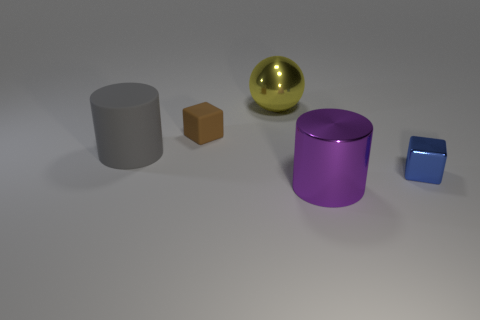What number of brown things are either tiny shiny things or tiny matte things?
Give a very brief answer. 1. How many big matte things have the same color as the tiny metallic block?
Ensure brevity in your answer.  0. Is there anything else that is the same shape as the big gray object?
Ensure brevity in your answer.  Yes. What number of spheres are either tiny shiny things or big rubber objects?
Make the answer very short. 0. What is the color of the big cylinder that is to the right of the yellow ball?
Keep it short and to the point. Purple. What is the shape of the rubber object that is the same size as the purple metallic cylinder?
Make the answer very short. Cylinder. There is a big matte object; what number of large purple objects are to the right of it?
Provide a succinct answer. 1. How many objects are big cylinders or yellow matte cylinders?
Your response must be concise. 2. The big object that is both right of the rubber cylinder and in front of the small matte cube has what shape?
Give a very brief answer. Cylinder. What number of cyan rubber objects are there?
Make the answer very short. 0. 